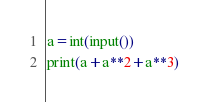<code> <loc_0><loc_0><loc_500><loc_500><_Python_>a=int(input())
print(a+a**2+a**3)</code> 